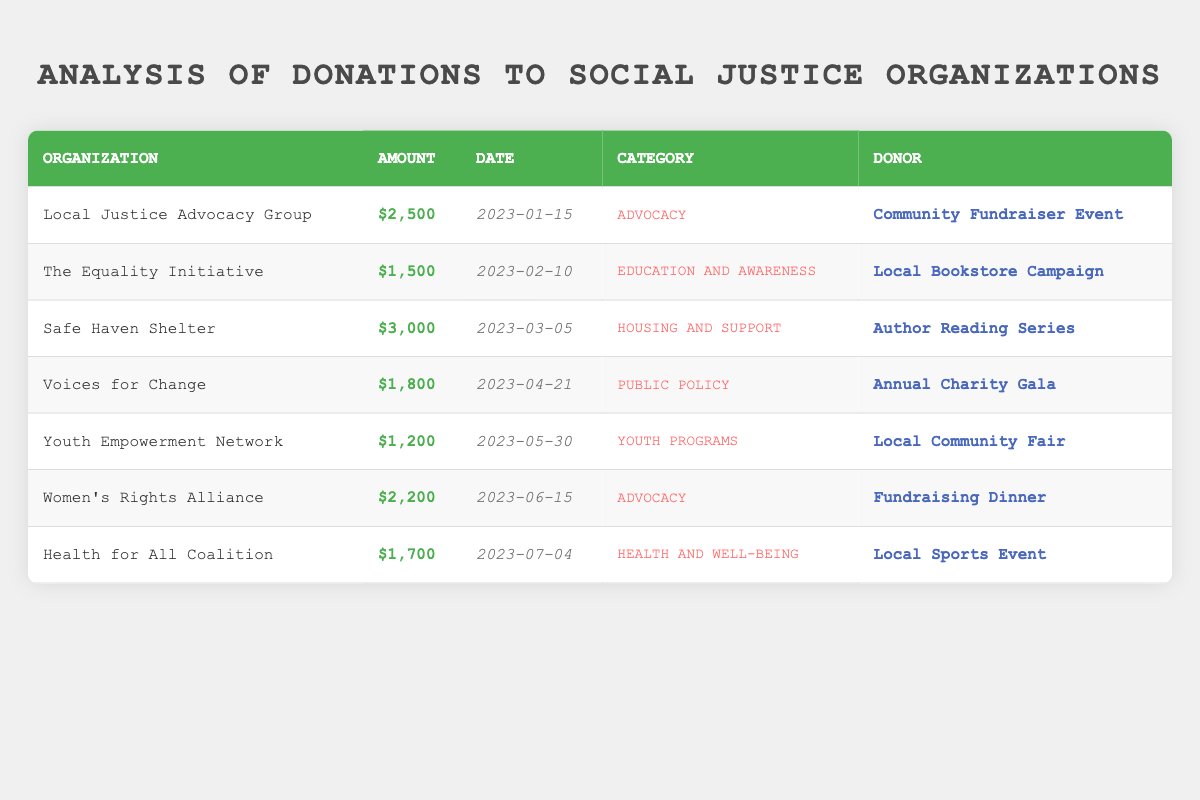What is the total amount donated to the "Safe Haven Shelter"? The table indicates that the donation amount to "Safe Haven Shelter" is $3,000, which can be found in the relevant row under the "Amount" column.
Answer: 3000 Which organization received the least amount of donations? By scanning through the "Amount" column, the lowest value appears to be $1,200, which corresponds to "Youth Empowerment Network."
Answer: Youth Empowerment Network How much more did the "Local Justice Advocacy Group" receive compared to "The Equality Initiative"? The "Local Justice Advocacy Group" received $2,500 and "The Equality Initiative" received $1,500. The difference is $2,500 - $1,500 = $1,000.
Answer: 1000 True or False: The "Health for All Coalition" was funded by a community fundraiser event. The "Health for All Coalition" was funded by a "Local Sports Event," not a community fundraiser event, so the statement is false.
Answer: False What is the average amount donated across all organizations listed? To find the average, sum all donation amounts ($2,500 + $1,500 + $3,000 + $1,800 + $1,200 + $2,200 + $1,700 = $13,900), then divide by the total number of donations (7): $13,900 / 7 ≈ $1,985.71.
Answer: 1985.71 How many donations were made to organizations in the "Advocacy" category? The table shows donations to two organizations categorized under "Advocacy": "Local Justice Advocacy Group" and "Women's Rights Alliance." Thus, there are a total of 2 donations.
Answer: 2 What is the total amount donated to organizations under the category "Youth Programs"? The only organization in the "Youth Programs" category is "Youth Empowerment Network," which received $1,200. Therefore, the total for this category is $1,200.
Answer: 1200 Which donor contributed the highest single donation? By checking the "Donor" and "Amount" columns, we find that "Safe Haven Shelter," funded by "Author Reading Series," received the highest donation of $3,000.
Answer: Author Reading Series 